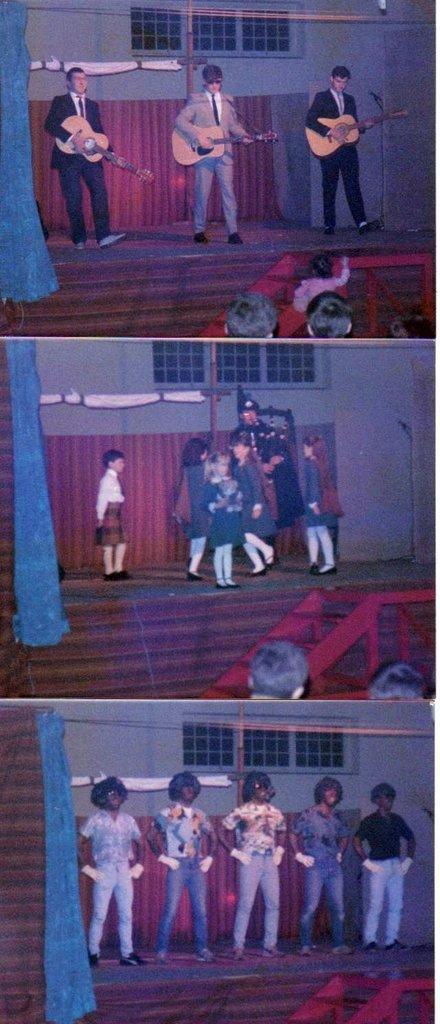Can you describe this image briefly? Here we can see three persons performing on a stage. They are playing a guitar. Here we can see a few children who are playing on the stage. Here we can see a five persons standing on the stage. 